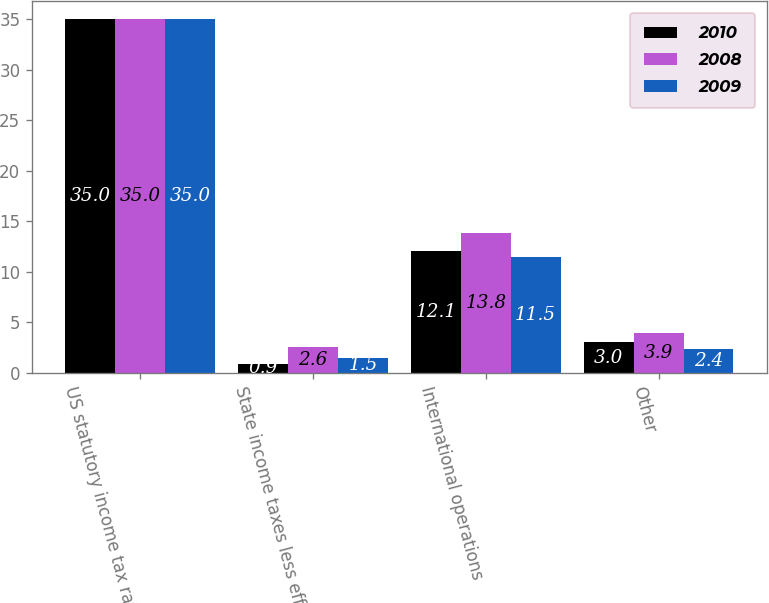Convert chart to OTSL. <chart><loc_0><loc_0><loc_500><loc_500><stacked_bar_chart><ecel><fcel>US statutory income tax rate<fcel>State income taxes less effect<fcel>International operations<fcel>Other<nl><fcel>2010<fcel>35<fcel>0.9<fcel>12.1<fcel>3<nl><fcel>2008<fcel>35<fcel>2.6<fcel>13.8<fcel>3.9<nl><fcel>2009<fcel>35<fcel>1.5<fcel>11.5<fcel>2.4<nl></chart> 